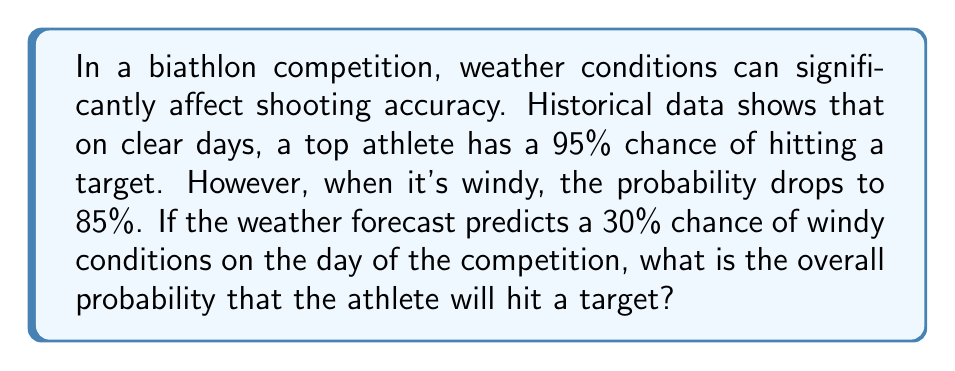What is the answer to this math problem? Let's approach this step-by-step using the law of total probability:

1) Define events:
   A: The athlete hits the target
   W: It's windy
   C: It's clear (not windy)

2) Given probabilities:
   P(A|C) = 0.95 (probability of hitting given clear conditions)
   P(A|W) = 0.85 (probability of hitting given windy conditions)
   P(W) = 0.30 (probability of windy conditions)
   P(C) = 1 - P(W) = 0.70 (probability of clear conditions)

3) Apply the law of total probability:
   P(A) = P(A|C) * P(C) + P(A|W) * P(W)

4) Substitute the values:
   P(A) = 0.95 * 0.70 + 0.85 * 0.30

5) Calculate:
   P(A) = 0.665 + 0.255 = 0.92

Therefore, the overall probability that the athlete will hit a target is 0.92 or 92%.
Answer: 0.92 